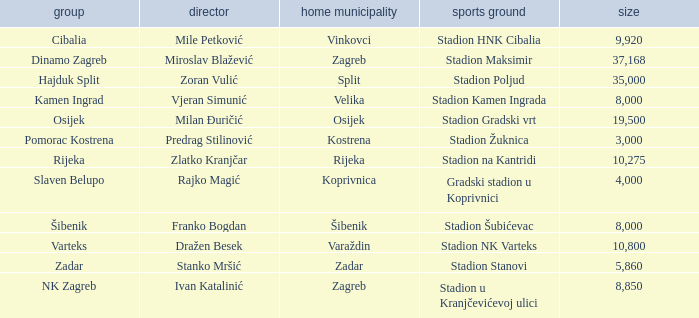Parse the table in full. {'header': ['group', 'director', 'home municipality', 'sports ground', 'size'], 'rows': [['Cibalia', 'Mile Petković', 'Vinkovci', 'Stadion HNK Cibalia', '9,920'], ['Dinamo Zagreb', 'Miroslav Blažević', 'Zagreb', 'Stadion Maksimir', '37,168'], ['Hajduk Split', 'Zoran Vulić', 'Split', 'Stadion Poljud', '35,000'], ['Kamen Ingrad', 'Vjeran Simunić', 'Velika', 'Stadion Kamen Ingrada', '8,000'], ['Osijek', 'Milan Đuričić', 'Osijek', 'Stadion Gradski vrt', '19,500'], ['Pomorac Kostrena', 'Predrag Stilinović', 'Kostrena', 'Stadion Žuknica', '3,000'], ['Rijeka', 'Zlatko Kranjčar', 'Rijeka', 'Stadion na Kantridi', '10,275'], ['Slaven Belupo', 'Rajko Magić', 'Koprivnica', 'Gradski stadion u Koprivnici', '4,000'], ['Šibenik', 'Franko Bogdan', 'Šibenik', 'Stadion Šubićevac', '8,000'], ['Varteks', 'Dražen Besek', 'Varaždin', 'Stadion NK Varteks', '10,800'], ['Zadar', 'Stanko Mršić', 'Zadar', 'Stadion Stanovi', '5,860'], ['NK Zagreb', 'Ivan Katalinić', 'Zagreb', 'Stadion u Kranjčevićevoj ulici', '8,850']]} What team has a home city of Koprivnica? Slaven Belupo. 